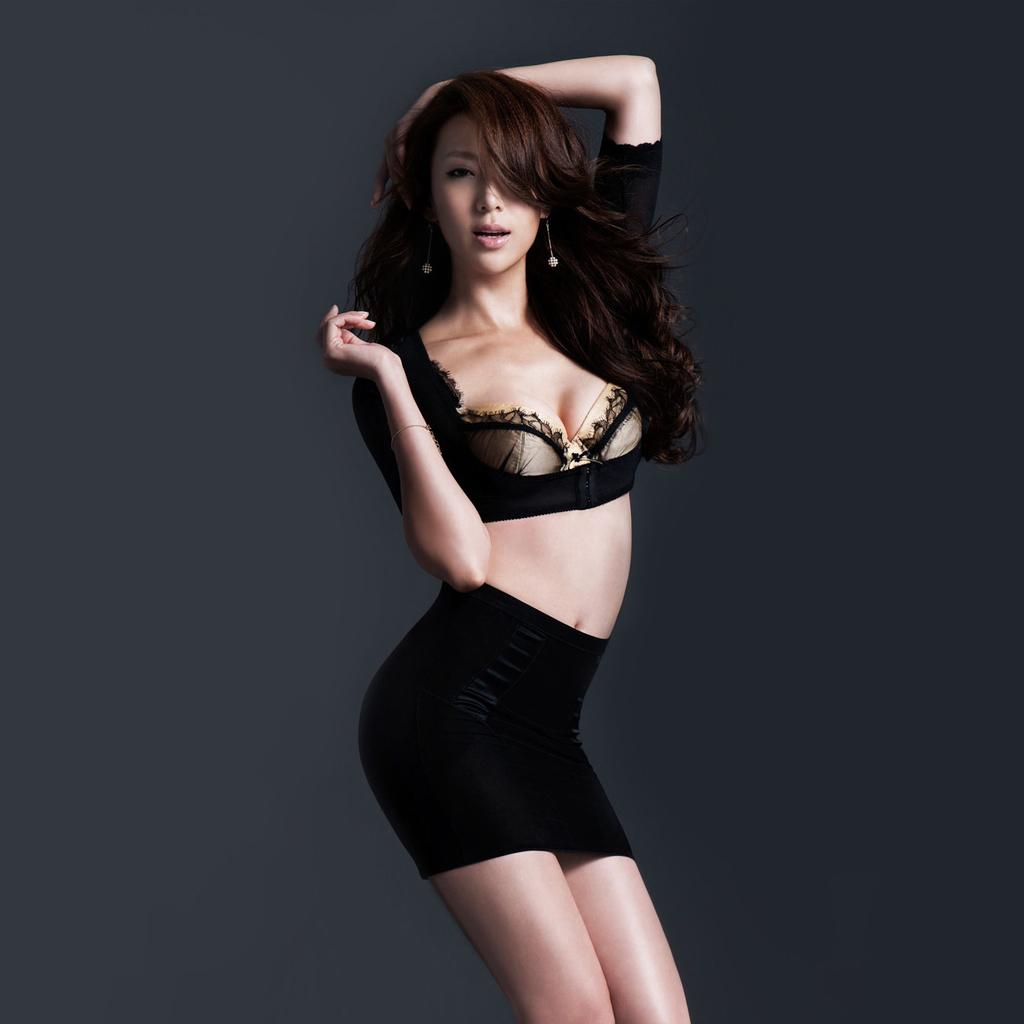What is the main subject of the image? There is a girl standing in the image. What can be observed about the background of the image? The background of the image is in gray color. What type of scissors is the girl using in the image? There are no scissors present in the image. What experience is the girl celebrating in the image? There is no indication of a celebration or experience in the image. 